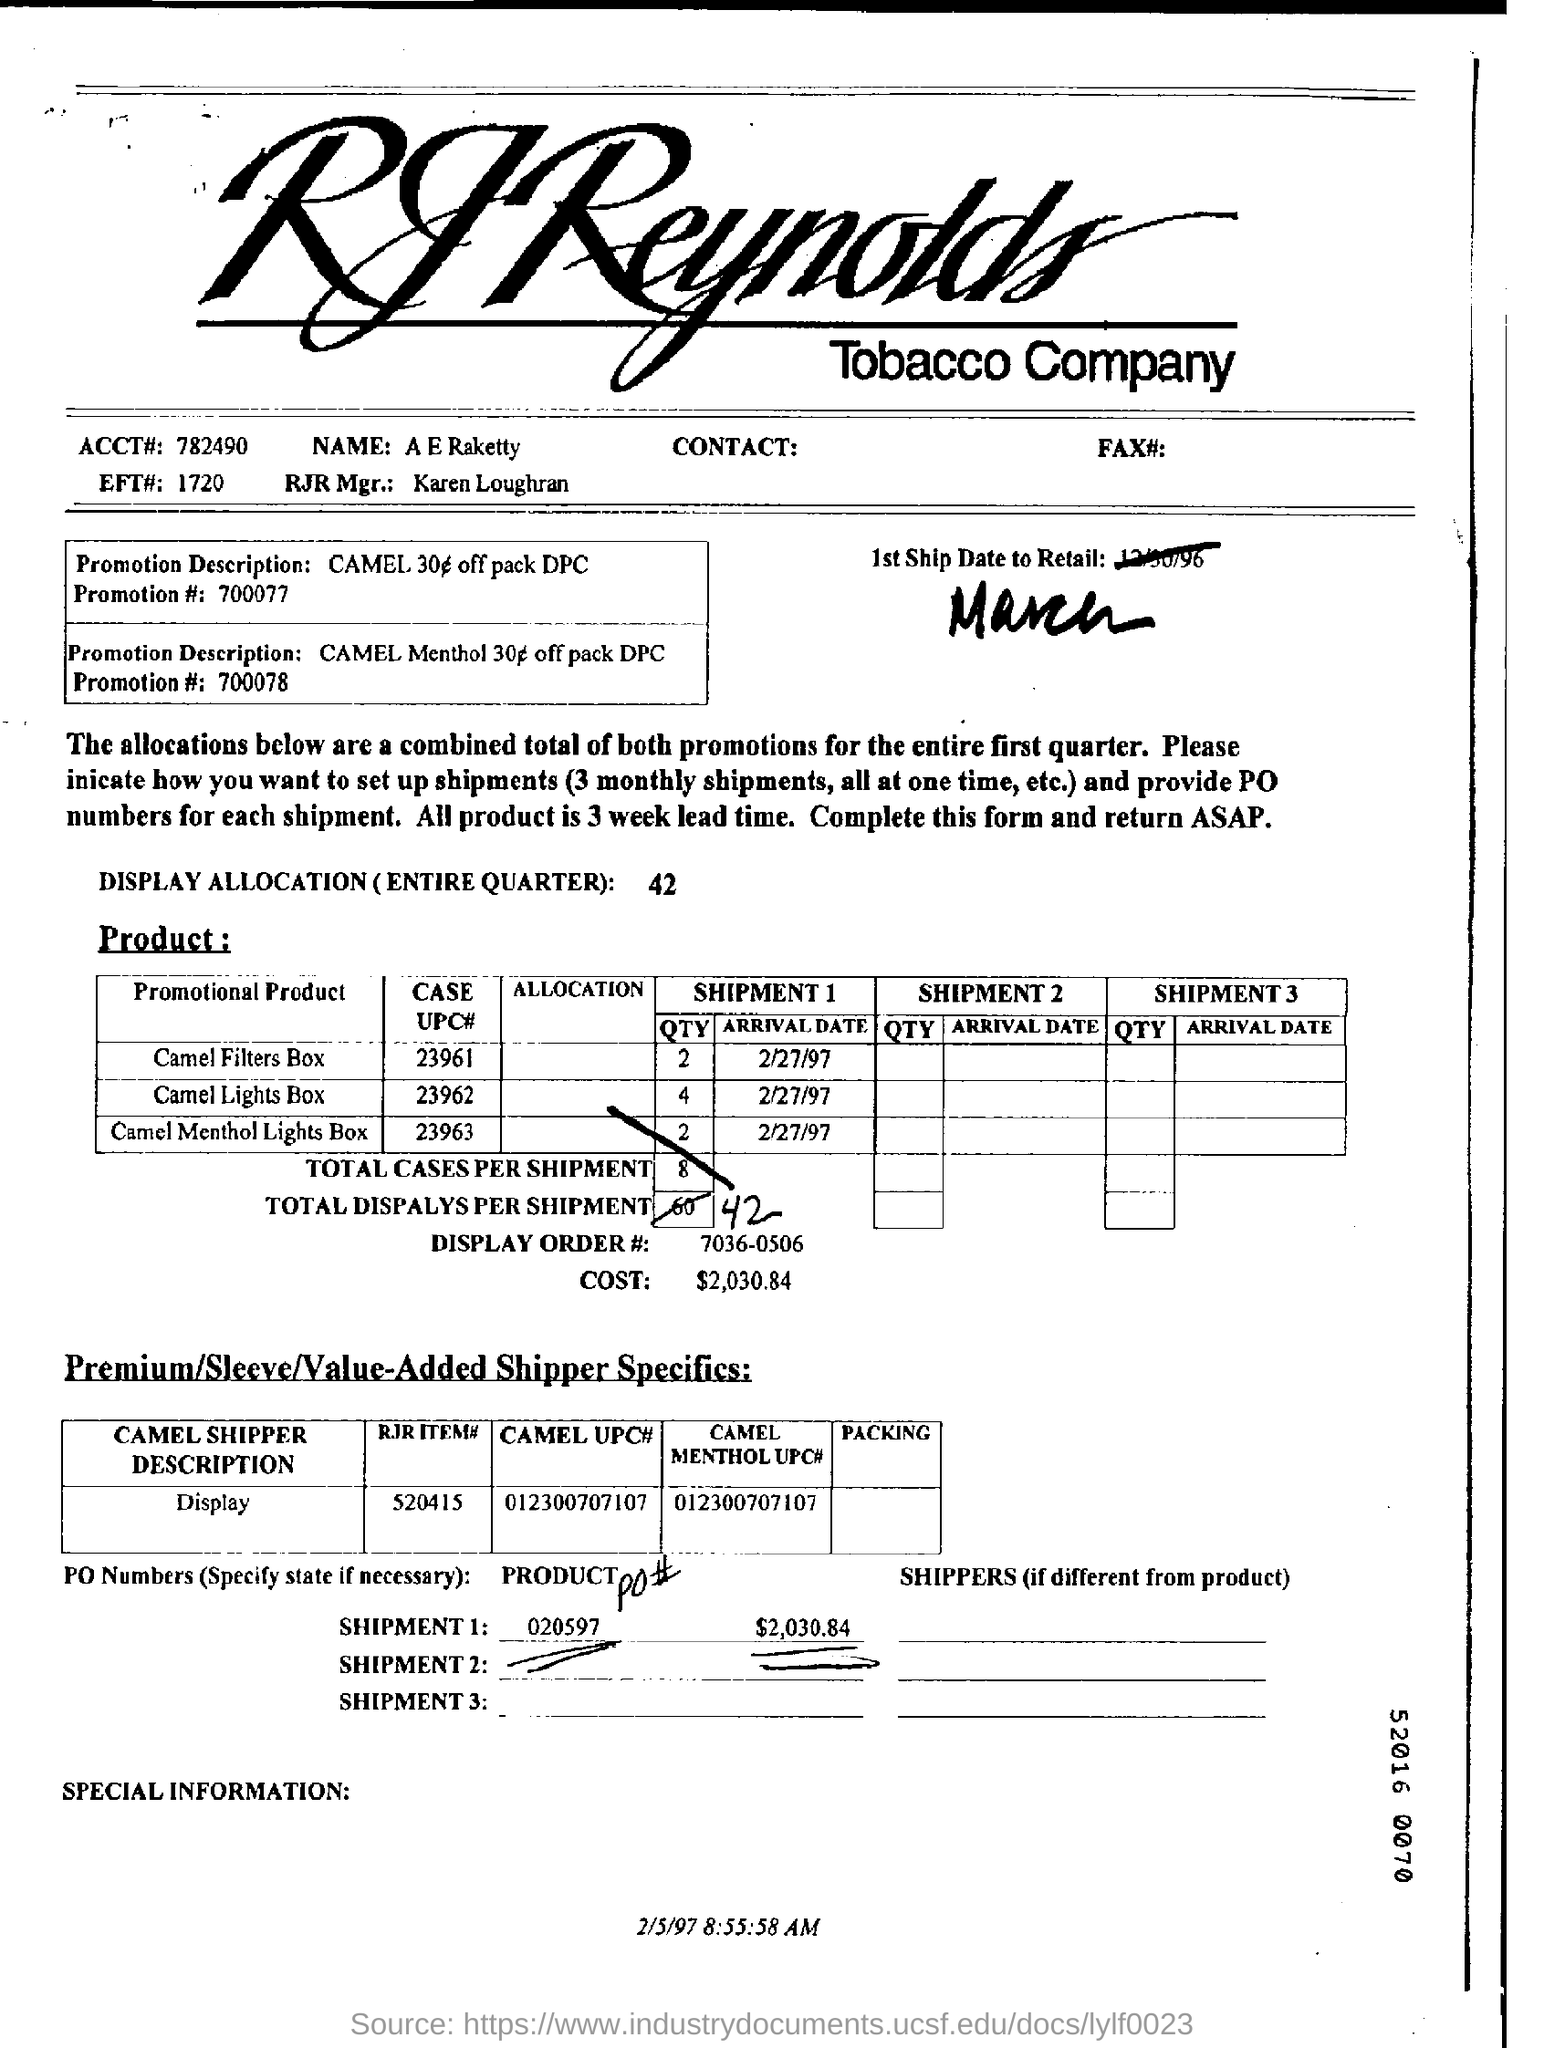What is the display allocation for entire quarter?
Your answer should be compact. 42. How much is the total cost for shipment 1?
Your answer should be compact. $2,030.84. How many total number of cases per shipment are mentioned in the form?
Provide a short and direct response. 8. Who is the RJR manager?
Ensure brevity in your answer.  Karen loughran. When is the form dated?
Make the answer very short. 2/5/97. 